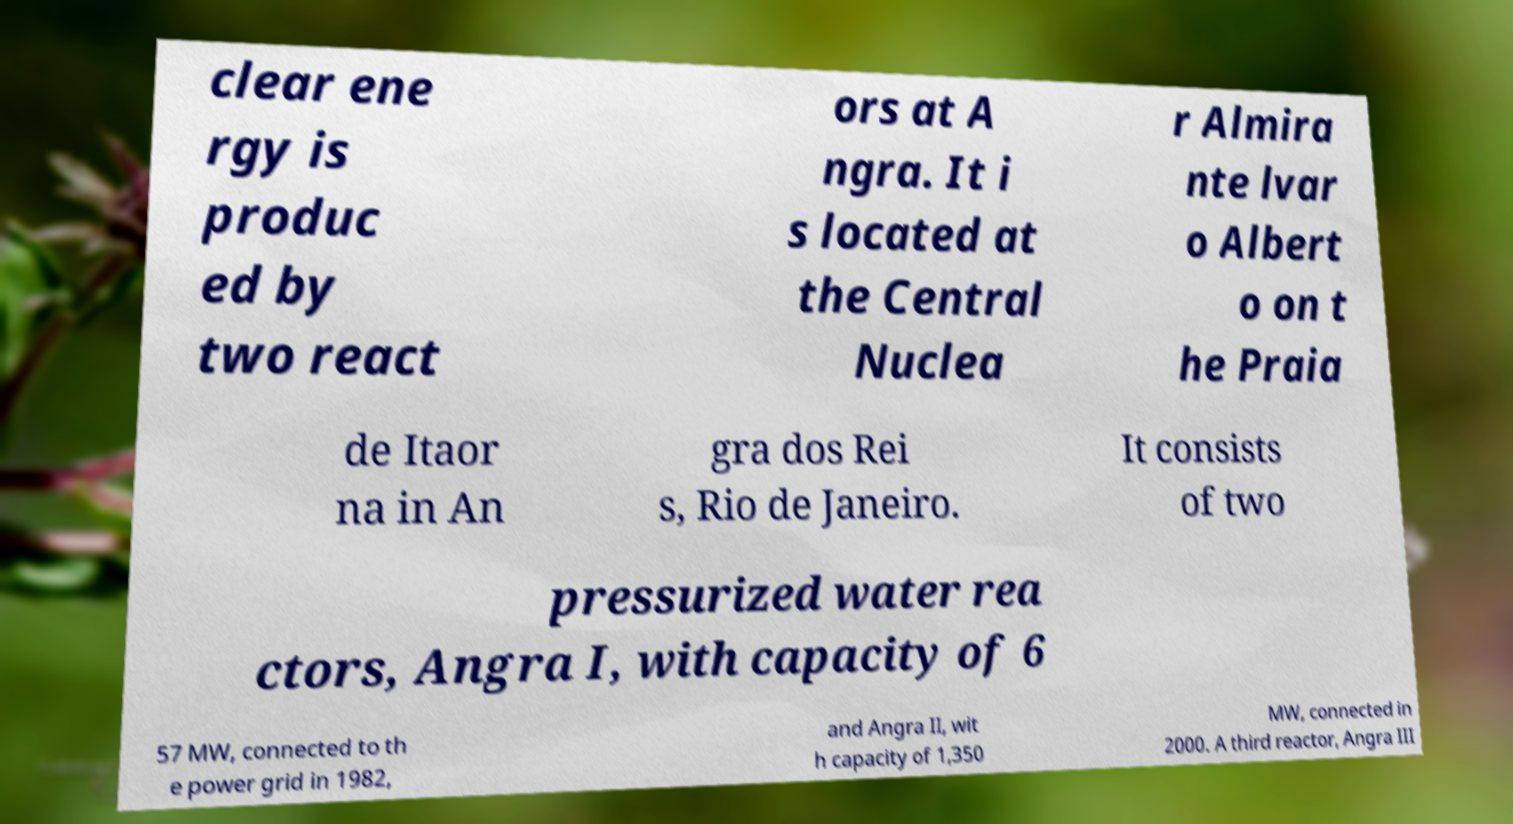Please identify and transcribe the text found in this image. clear ene rgy is produc ed by two react ors at A ngra. It i s located at the Central Nuclea r Almira nte lvar o Albert o on t he Praia de Itaor na in An gra dos Rei s, Rio de Janeiro. It consists of two pressurized water rea ctors, Angra I, with capacity of 6 57 MW, connected to th e power grid in 1982, and Angra II, wit h capacity of 1,350 MW, connected in 2000. A third reactor, Angra III 